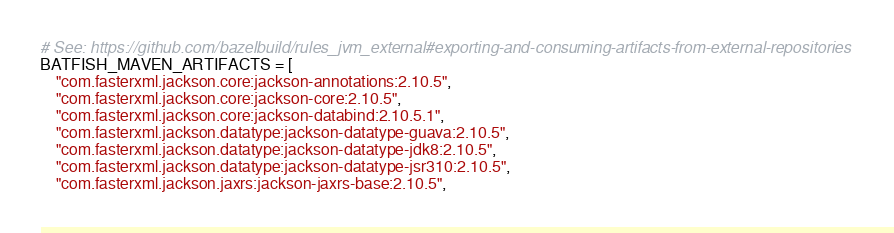Convert code to text. <code><loc_0><loc_0><loc_500><loc_500><_Python_># See: https://github.com/bazelbuild/rules_jvm_external#exporting-and-consuming-artifacts-from-external-repositories
BATFISH_MAVEN_ARTIFACTS = [
    "com.fasterxml.jackson.core:jackson-annotations:2.10.5",
    "com.fasterxml.jackson.core:jackson-core:2.10.5",
    "com.fasterxml.jackson.core:jackson-databind:2.10.5.1",
    "com.fasterxml.jackson.datatype:jackson-datatype-guava:2.10.5",
    "com.fasterxml.jackson.datatype:jackson-datatype-jdk8:2.10.5",
    "com.fasterxml.jackson.datatype:jackson-datatype-jsr310:2.10.5",
    "com.fasterxml.jackson.jaxrs:jackson-jaxrs-base:2.10.5",</code> 